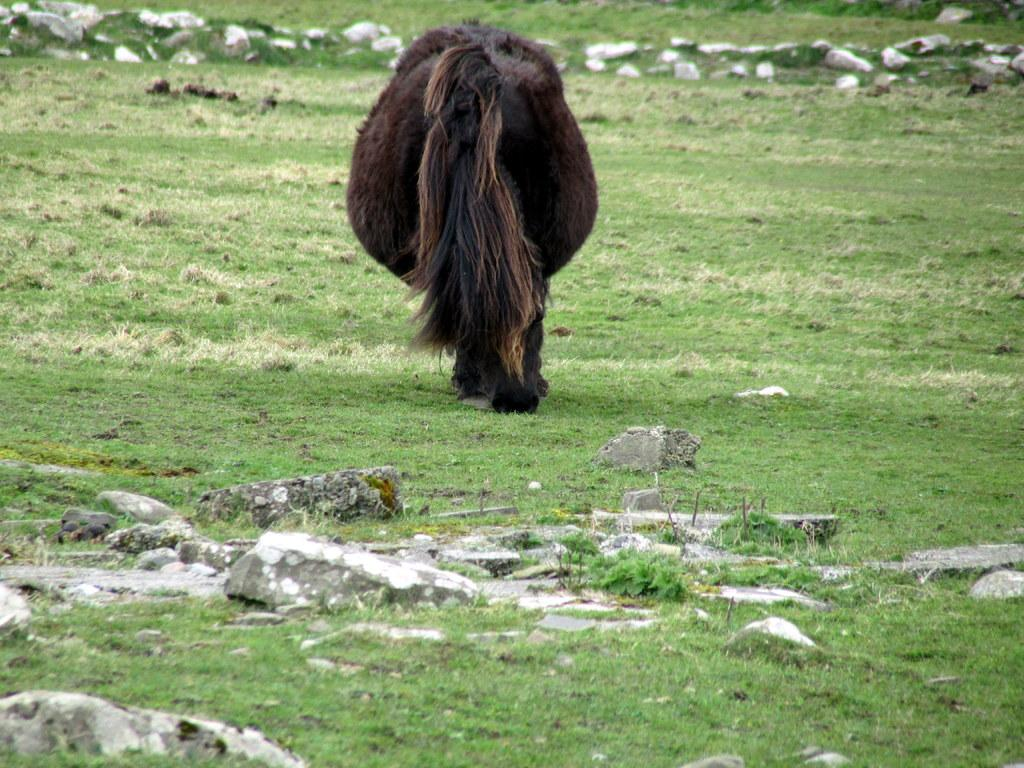What type of creature is in the image? There is an animal in the image. How is the animal positioned in the image? The image shows the back view of the animal. What can be seen in the background of the image? There are rocks and greenery in the area of the image. What type of writer is depicted in the image? There is no writer depicted in the image; it features an animal from the back view. Is there a prison visible in the image? There is no prison present in the image; it shows an animal and its surroundings. 